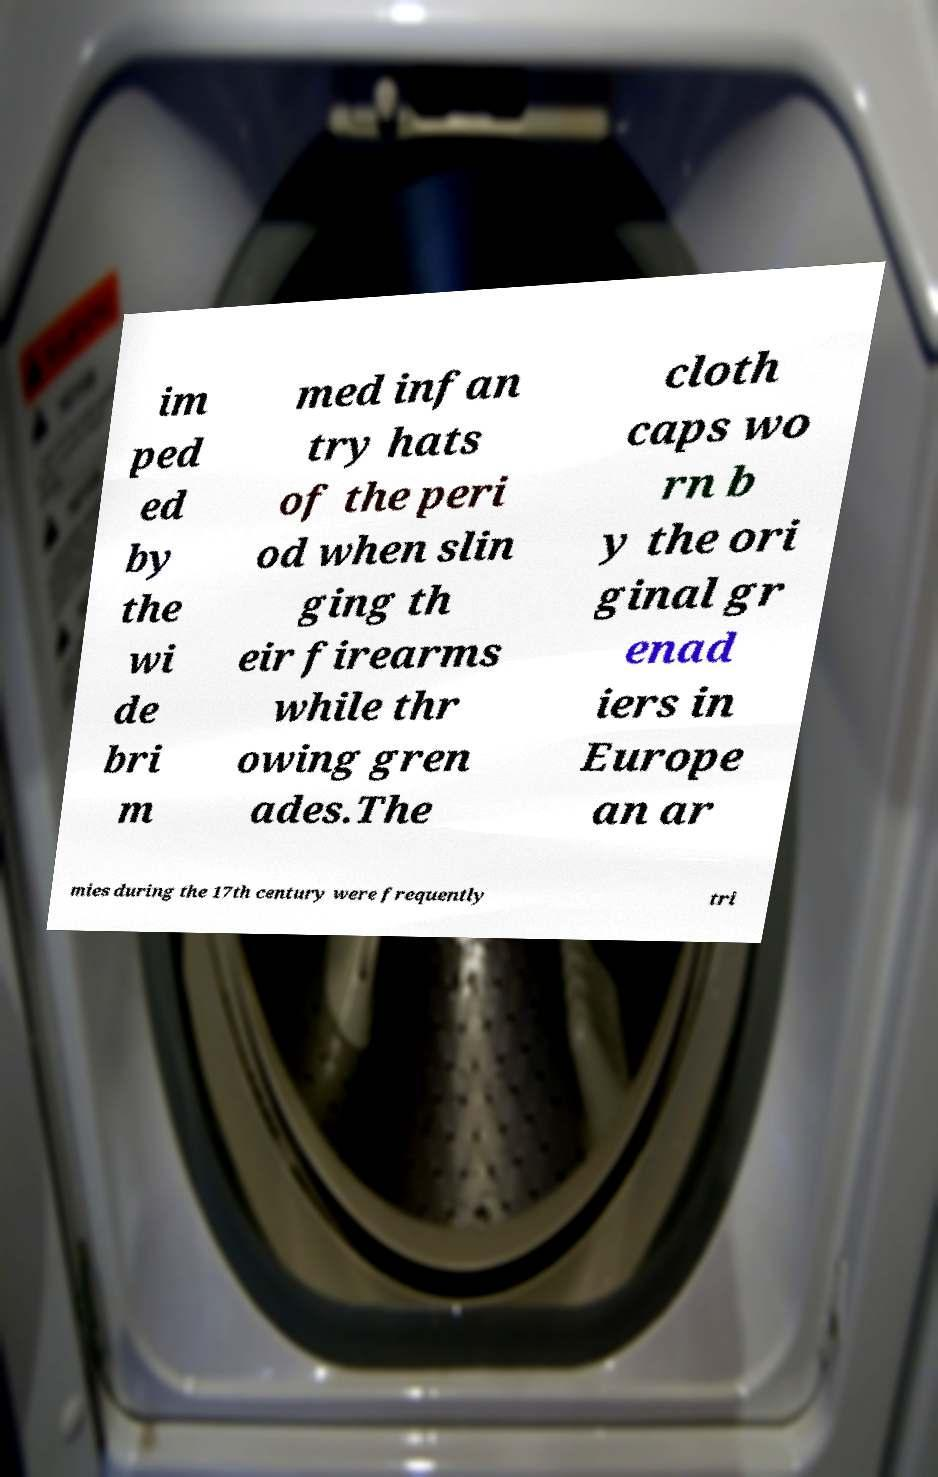Please identify and transcribe the text found in this image. im ped ed by the wi de bri m med infan try hats of the peri od when slin ging th eir firearms while thr owing gren ades.The cloth caps wo rn b y the ori ginal gr enad iers in Europe an ar mies during the 17th century were frequently tri 